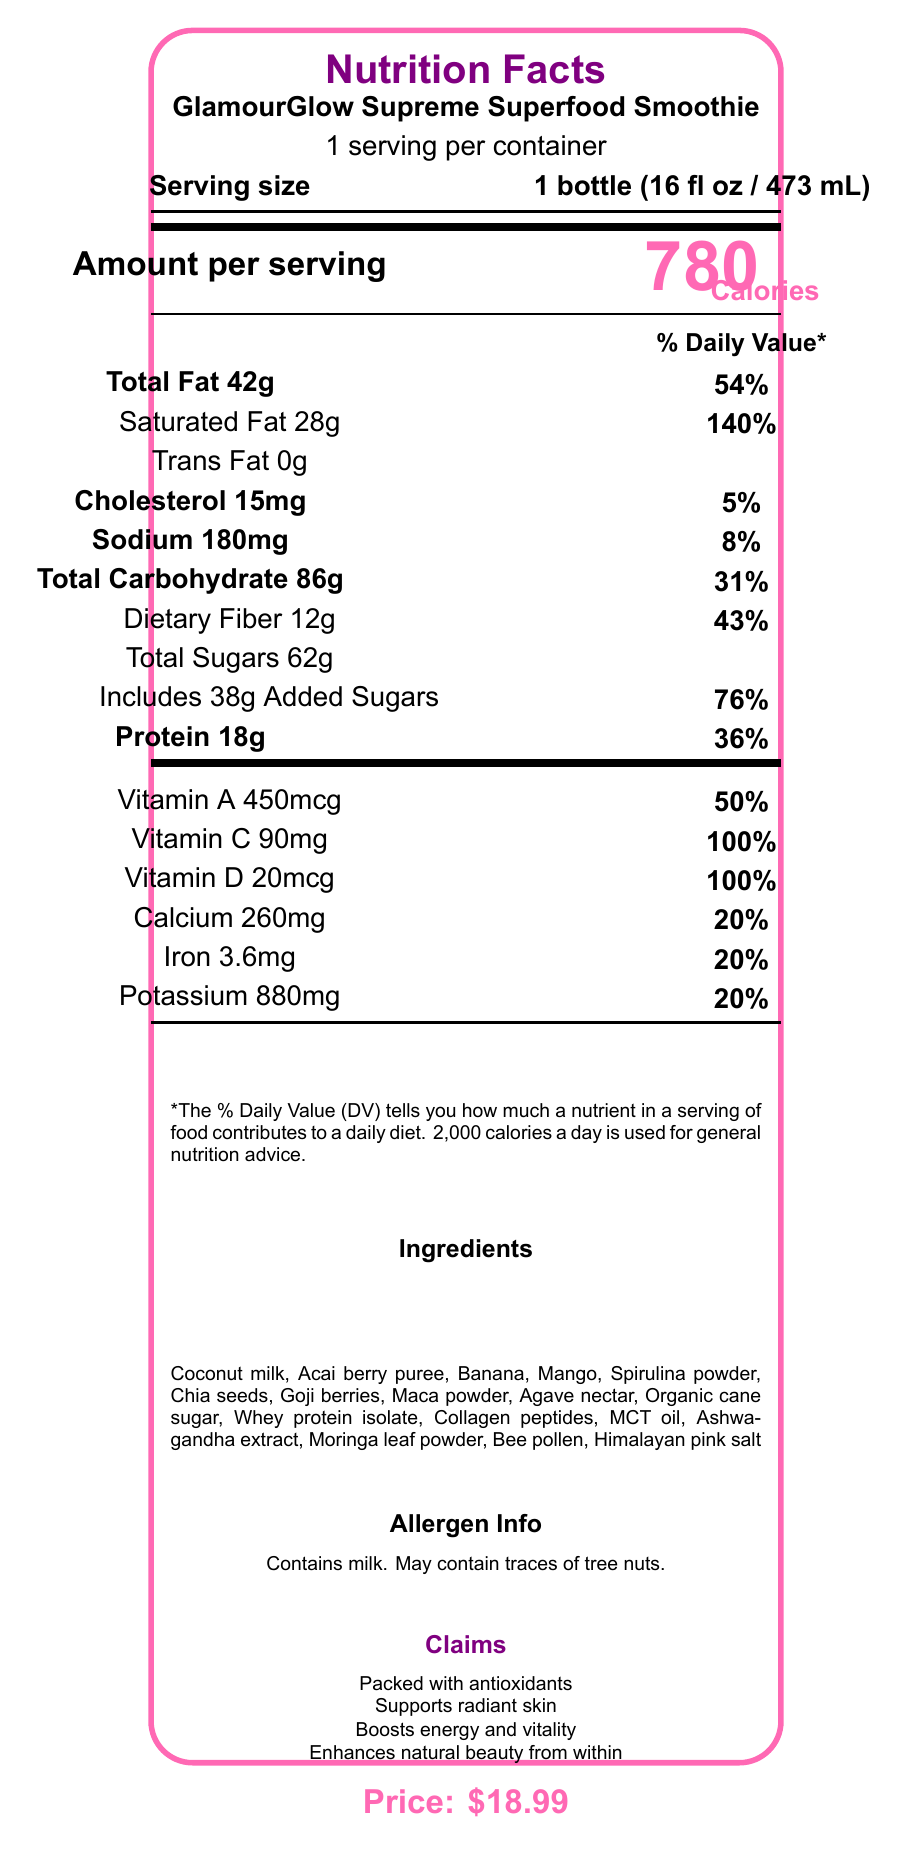what is the serving size? The serving size is explicitly mentioned in the document as "1 bottle (16 fl oz / 473 mL)".
Answer: 1 bottle (16 fl oz / 473 mL) how many calories are in one serving of the smoothie? The calorie content per serving is clearly stated as 780 calories.
Answer: 780 what percentage of daily value of saturated fat does this product contain? The document indicates that the smoothie contains 140% of the daily value for saturated fat.
Answer: 140% how much protein does the smoothie provide per serving? The protein content per serving is listed as 18 grams.
Answer: 18g what are the main ingredients in this smoothie? The ingredient list is provided toward the bottom of the document.
Answer: Coconut milk, Acai berry puree, Banana, Mango, Spirulina powder, Chia seeds, Goji berries, Maca powder, Agave nectar, Organic cane sugar, Whey protein isolate, Collagen peptides, MCT oil, Ashwagandha extract, Moringa leaf powder, Bee pollen, Himalayan pink salt how much does one bottle of this smoothie cost? The price is mentioned at the very bottom of the document, listed as $18.99.
Answer: $18.99 what is the percentage of daily value for dietary fiber in each serving? A. 31% B. 43% C. 54% D. 76% The daily value percentage for dietary fiber is given as 43%.
Answer: B which vitamin is present in the highest quantity in terms of percentage of daily value? A. Vitamin A B. Vitamin C C. Vitamin D D. Calcium Vitamin C is present at 100% daily value, which is the highest among the listed percentages.
Answer: B does the smoothie contain any allergens? The document mentions that the product contains milk and may contain traces of tree nuts.
Answer: Yes describe the main idea of the document The document is a detailed nutrition facts label, aimed at informing consumers about the nutritional value and composition of the product.
Answer: The document provides the nutrition facts for "GlamourGlow Supreme Superfood Smoothie," highlighting all nutritional contents per serving, including calories, fats, carbohydrates, proteins, and vitamins. The ingredients list and allergen information are also provided, along with the product’s claims about health benefits and the price. how many grams of added sugars does the smoothie have? The document states that there are 38 grams of added sugars in the smoothie.
Answer: 38g what is the total fat content and its percentage of daily value? The total fat content is 42 grams and this constitutes 54% of the daily value.
Answer: 42g, 54% how many servings are there per container? The document mentions that there is 1 serving per container.
Answer: 1 what health claims does the smoothie make? The health claims are listed under the "Claims" section near the bottom part of the document.
Answer: Packed with antioxidants, Supports radiant skin, Boosts energy and vitality, Enhances natural beauty from within how much potassium does the smoothie contain? The potassium content is stated as 880 milligrams.
Answer: 880mg is this smoothie low in cholesterol? The smoothie contains 15mg of cholesterol, which is 5% of the daily value, indicating it’s relatively low.
Answer: Yes, relatively low what is the purpose of this document? The purpose of the document is not explicitly stated but can be inferred to be providing nutritional information about the product.
Answer: Not enough information what is the impact of consuming one bottle of this smoothie on daily calorie intake? At 780 calories per bottle, this smoothie constitutes a significant part of the typical daily calorie intake of 2,000 calories.
Answer: Significant 